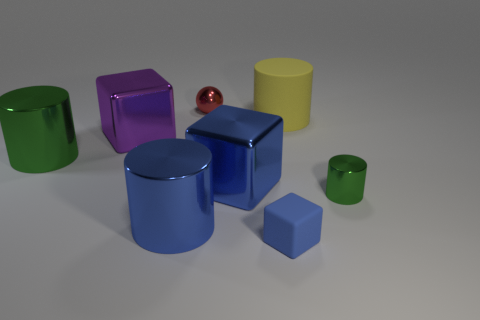The metallic object that is the same size as the red shiny ball is what shape?
Give a very brief answer. Cylinder. Is there a big purple shiny object of the same shape as the red shiny object?
Provide a succinct answer. No. Is the color of the metallic thing that is in front of the tiny cylinder the same as the big cube that is on the left side of the red thing?
Make the answer very short. No. There is a yellow cylinder; are there any large shiny cylinders right of it?
Provide a succinct answer. No. There is a small thing that is on the left side of the large yellow object and in front of the big green metallic object; what is its material?
Offer a very short reply. Rubber. Are the big cylinder that is to the right of the red metal object and the ball made of the same material?
Your answer should be very brief. No. What is the tiny sphere made of?
Keep it short and to the point. Metal. There is a green cylinder that is left of the blue matte block; how big is it?
Keep it short and to the point. Large. Are there any other things that have the same color as the small cylinder?
Your answer should be very brief. Yes. Are there any large purple metallic blocks on the left side of the big shiny thing behind the green object on the left side of the red sphere?
Your response must be concise. No. 